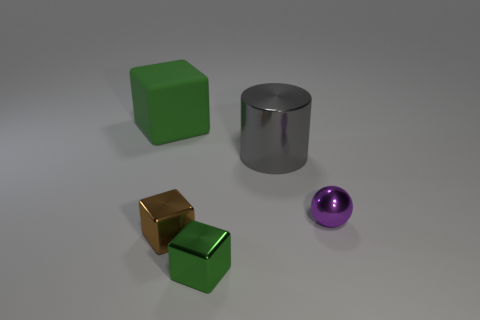Add 4 tiny purple metallic objects. How many objects exist? 9 Subtract all balls. How many objects are left? 4 Add 3 large cubes. How many large cubes are left? 4 Add 2 tiny red rubber cylinders. How many tiny red rubber cylinders exist? 2 Subtract 1 purple balls. How many objects are left? 4 Subtract all large blue shiny cylinders. Subtract all spheres. How many objects are left? 4 